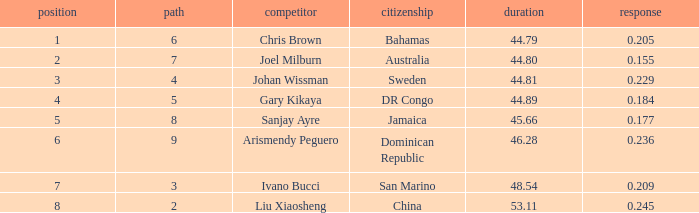How many total Rank listings have Liu Xiaosheng listed as the athlete with a react entry that is smaller than 0.245? 0.0. 